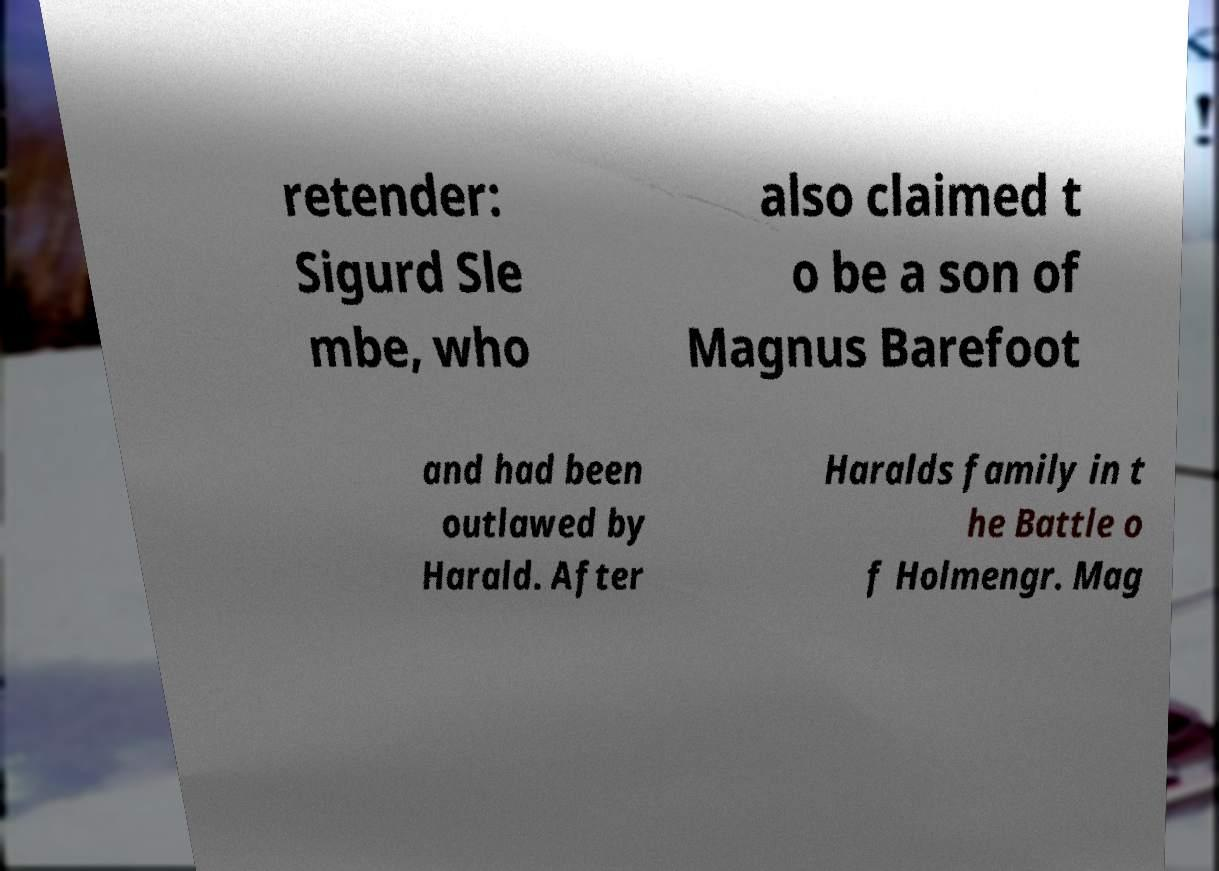Can you read and provide the text displayed in the image?This photo seems to have some interesting text. Can you extract and type it out for me? retender: Sigurd Sle mbe, who also claimed t o be a son of Magnus Barefoot and had been outlawed by Harald. After Haralds family in t he Battle o f Holmengr. Mag 